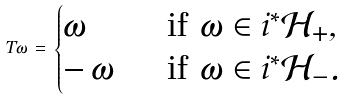<formula> <loc_0><loc_0><loc_500><loc_500>T \omega \, = \, \begin{cases} \omega \, & \text { if } \omega \in i ^ { * } { \mathcal { H } } _ { + } , \\ - \, \omega \, & \text { if } \omega \in i ^ { * } { \mathcal { H } } _ { - } . \end{cases}</formula> 